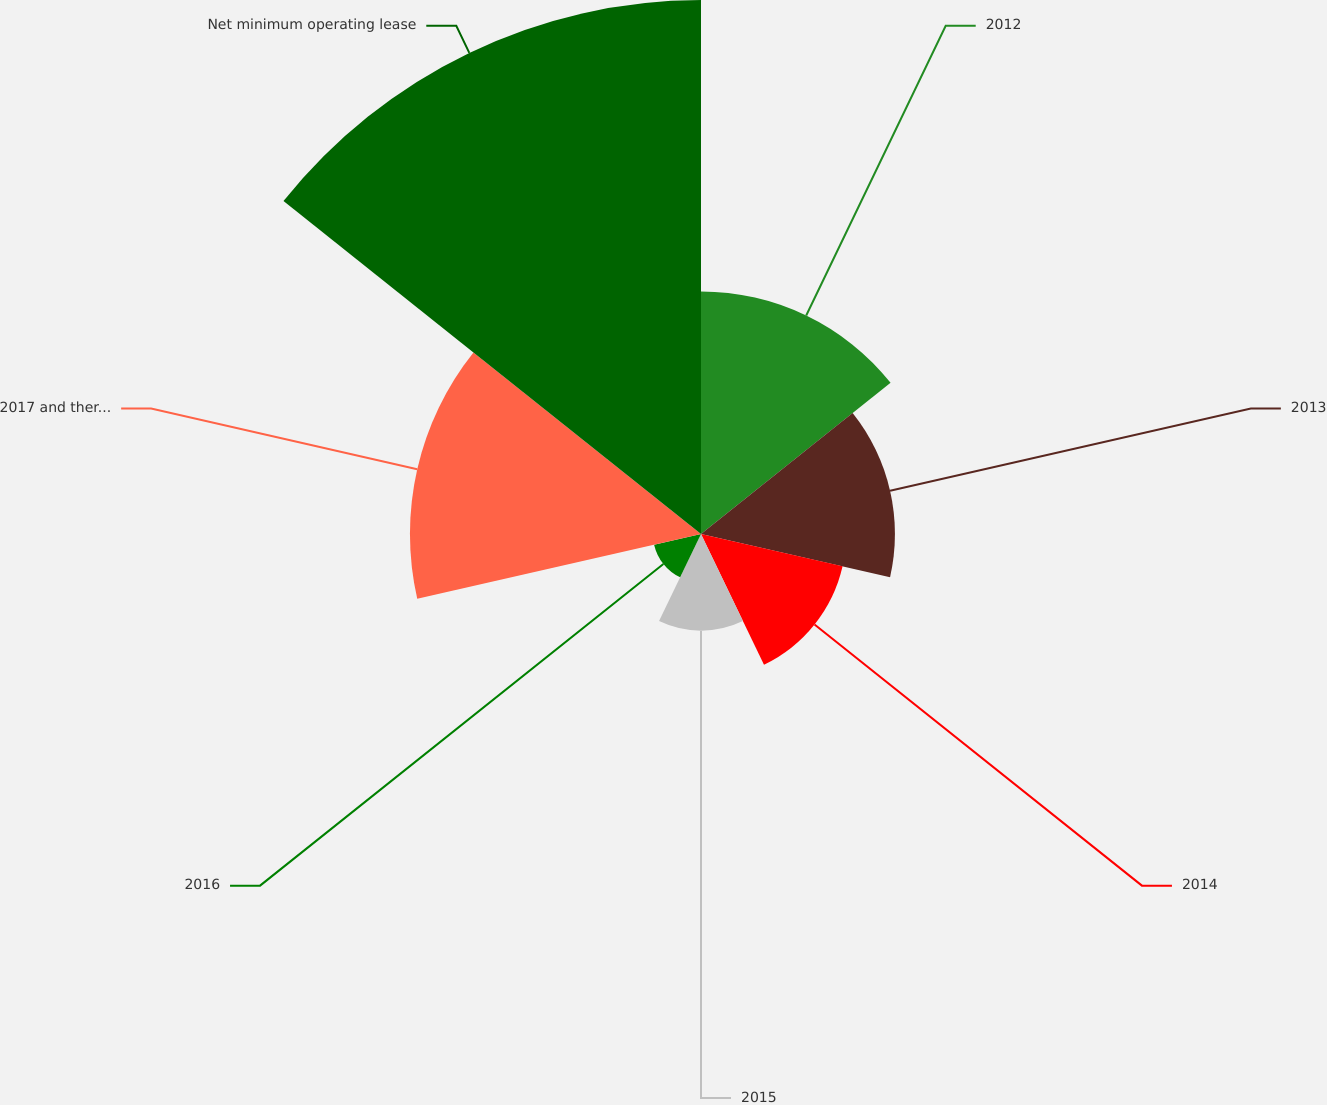<chart> <loc_0><loc_0><loc_500><loc_500><pie_chart><fcel>2012<fcel>2013<fcel>2014<fcel>2015<fcel>2016<fcel>2017 and thereafter<fcel>Net minimum operating lease<nl><fcel>15.63%<fcel>12.5%<fcel>9.36%<fcel>6.23%<fcel>3.1%<fcel>18.76%<fcel>34.42%<nl></chart> 